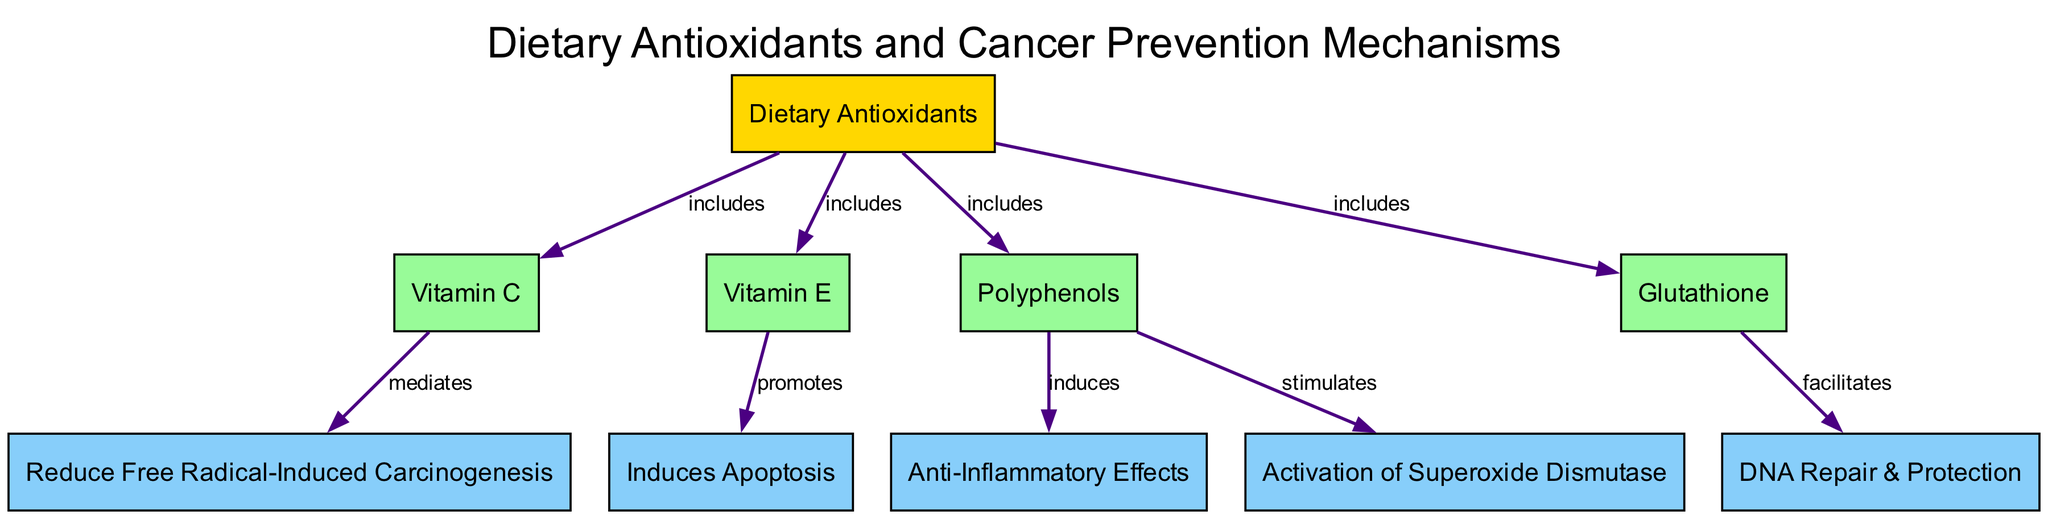What are the dietary antioxidants included in this diagram? The diagram lists four dietary antioxidants: Vitamin C, Vitamin E, Polyphenols, and Glutathione, which are all categorized under 'Dietary Antioxidants' and connected with 'includes' edges.
Answer: Vitamin C, Vitamin E, Polyphenols, Glutathione How many mechanisms are linked to the dietary antioxidants? The diagram shows five mechanisms: Reduce Free Radical-Induced Carcinogenesis, Induces Apoptosis, Anti-Inflammatory Effects, DNA Repair & Protection, and Activation of Superoxide Dismutase, meaning there are a total of five mechanisms.
Answer: 5 Which antioxidant is linked to the mechanism of DNA Repair & Protection? According to the edges in the diagram, Glutathione is linked to the DNA Repair & Protection mechanism with a 'facilitates' edge.
Answer: Glutathione What mechanism does Vitamin C mediate? The diagram indicates that Vitamin C mediates the mechanism called Reduce Free Radical-Induced Carcinogenesis, connected by an edge labeled 'mediates'.
Answer: Reduce Free Radical-Induced Carcinogenesis Which antioxidant promotes apoptosis? The diagram specifies that Vitamin E promotes the mechanism Induces Apoptosis, represented by the 'promotes' edge leading from Vitamin E.
Answer: Vitamin E What effect do Polyphenols induce in relation to inflammation? The connection labeled 'induces' shows that Polyphenols are linked to the mechanism of Anti-Inflammatory Effects, indicating their effect on inflammation.
Answer: Anti-Inflammatory Effects Which antioxidant stimulates the activation of Superoxide Dismutase? The edge labeled 'stimulates' in the diagram points out that Polyphenols stimulate the activation of Superoxide Dismutase mechanism.
Answer: Polyphenols 